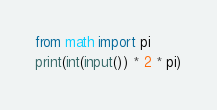Convert code to text. <code><loc_0><loc_0><loc_500><loc_500><_Python_>from math import pi
print(int(input()) * 2 * pi)</code> 